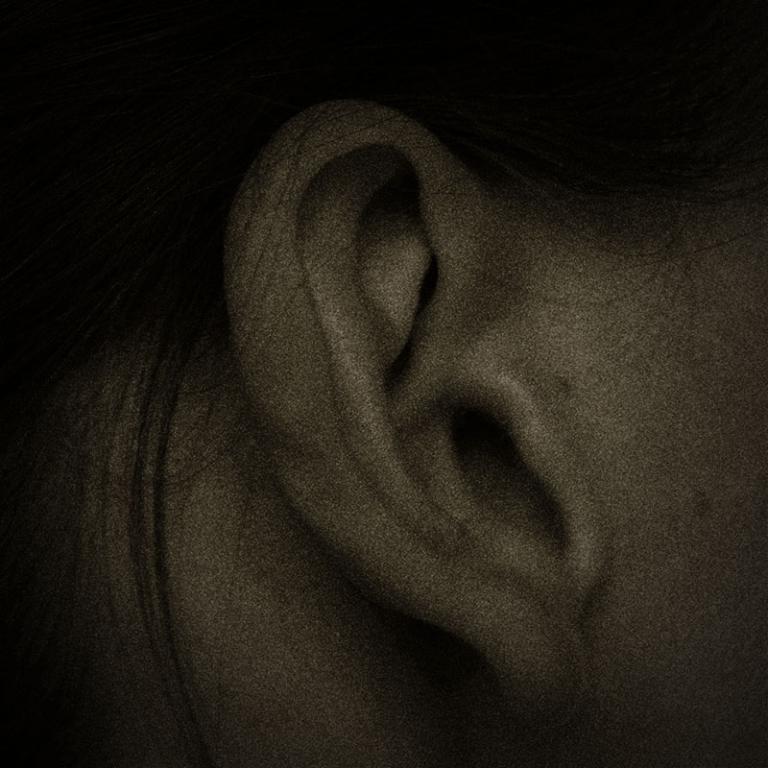Please provide a concise description of this image. In this image we can see an ear of a person. 